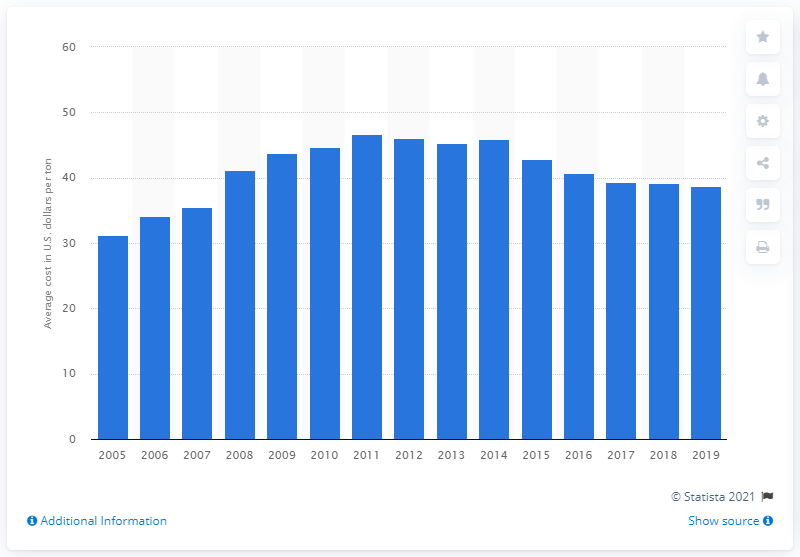Outline some significant characteristics in this image. In 2011, the average cost of coal for the electric power industry was 46.65. In 2019, the average cost of coal per ton was 38.7 USD. 